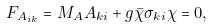<formula> <loc_0><loc_0><loc_500><loc_500>F _ { A _ { i k } } = M _ { A } A _ { k i } + g \bar { \chi } \sigma _ { k i } \chi = 0 ,</formula> 